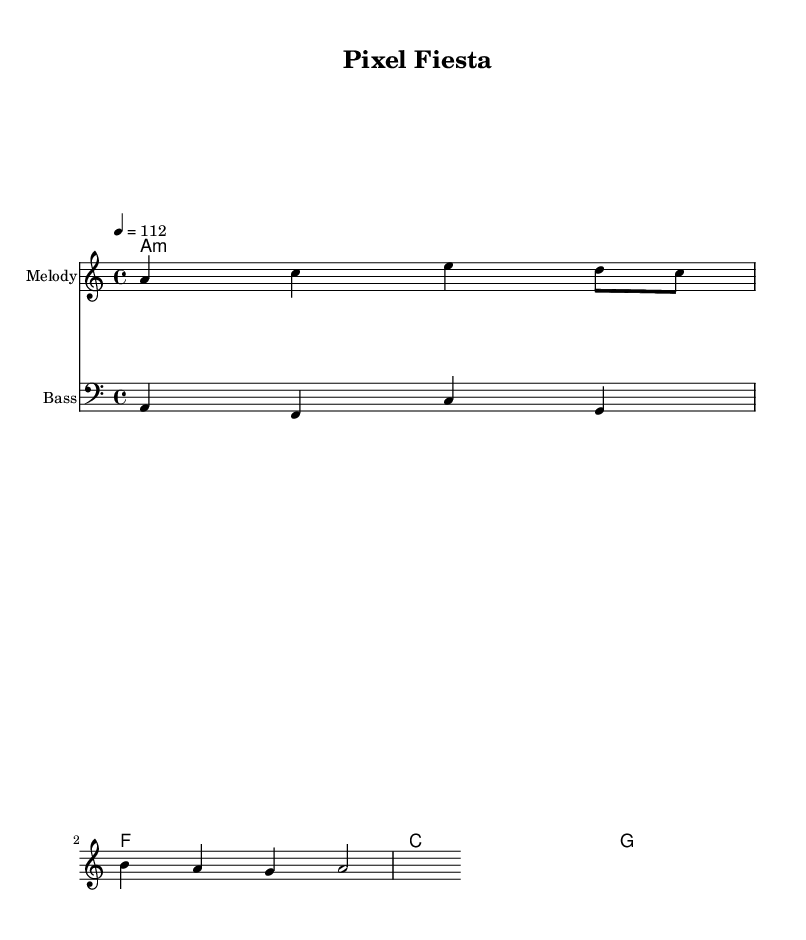what is the key signature of this music? The key signature is A minor, which has no sharps or flats. This can be identified from the "a" in the global music section of the code and by checking the relative minor of C major, which has no accidentals.
Answer: A minor what is the time signature of this music? The time signature is 4/4, which is explicitly noted in the global music section of the code. It indicates that there are four beats in each measure and a quarter note receives one beat.
Answer: 4/4 what is the tempo of this music? The tempo is 112 beats per minute, as indicated by "tempo 4 = 112" in the global settings of the code. This means the quarter note is played at a speed of 112 beats per minute.
Answer: 112 how many measures are in the melody section? There are four measures in the melody section as indicated by the structure of the notes and rhythms provided in the melody variable. Each measure can be counted from the first note to the last, considering the time signature is 4/4.
Answer: 4 how many chords are present in the harmonies section? There are four chords present in the harmonies section. This is evident from the chordmode notation, where each specified chord (A minor, F major, C major, G major) represents a measure.
Answer: 4 what is the lyric theme of the song? The lyric theme of the song revolves around "pixel dreams and joy stick schemes". These lyrics, which suggest nostalgia and gaming, can be inferred from the provided lyric section corresponding to the melody.
Answer: pixel dreams and joy stick schemes what kind of instruments is represented in this score? The score represents two types of instruments: a melody instrument (likely a lead instrument such as a synthesizer or lead guitar) and a bass instrument to provide harmonic support. These are indicated by the staff labels for each instrument.
Answer: Melody and Bass 